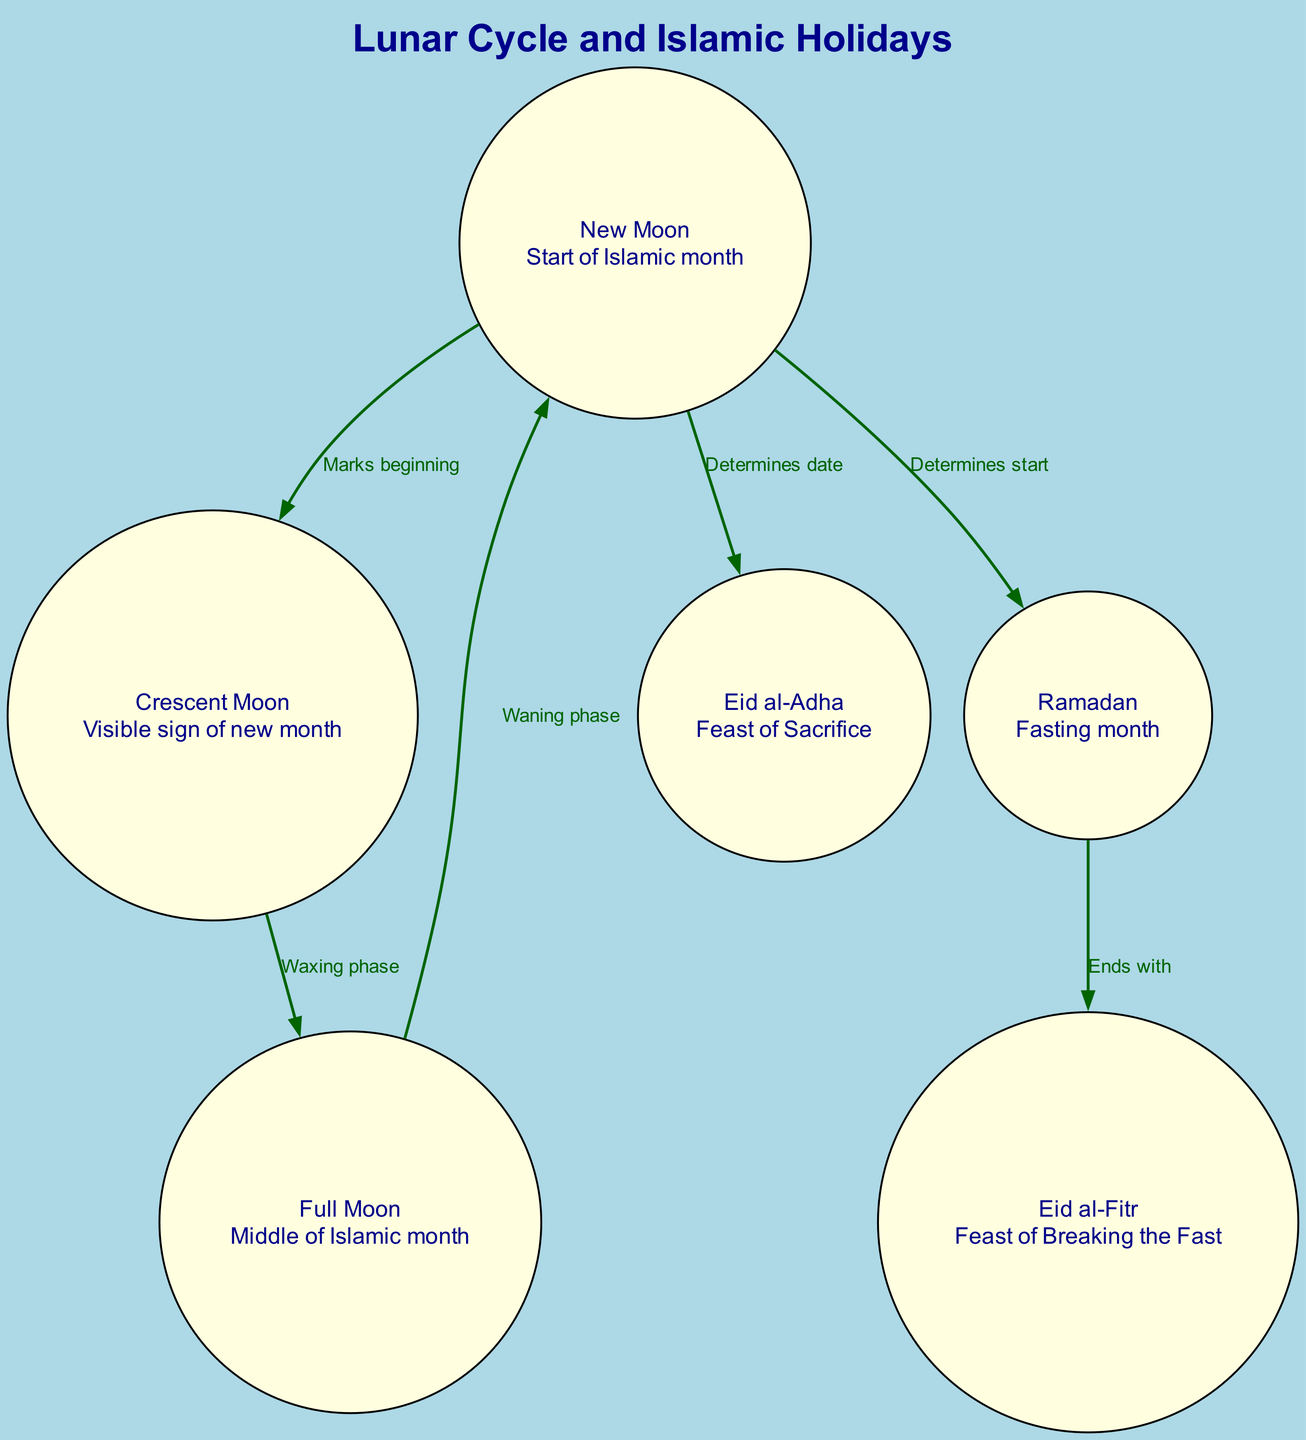What is the start of the Islamic month? The diagram explicitly labels "New Moon" as the starting point of the Islamic month, making it clear that the lunar cycle begins at this phase.
Answer: New Moon How many Islamic holidays are represented in the diagram? By counting the distinct nodes under the "Lunar Cycle and Islamic Holidays" concept, we find there are three key Islamic holidays: Ramadan, Eid al-Fitr, and Eid al-Adha.
Answer: 3 What phase comes after the Crescent Moon? The diagram illustrates that the Crescent Moon is followed by the Full Moon in the waxing phase, which indicates the progression of the lunar cycle towards fuller illumination.
Answer: Full Moon What event marks the end of Ramadan? The diagram connects the end of Ramadan directly to Eid al-Fitr, showcasing that this holiday is celebrated immediately after the fasting month concludes.
Answer: Eid al-Fitr Which phase of the moon determines the start of Ramadan? The edge from the New Moon to Ramadan indicates that the New Moon phase is what determines the beginning of the fasting month.
Answer: New Moon What relationship exists between New Moon and Eid al-Adha? The connection between the New Moon and Eid al-Adha shows that the New Moon phase determines the date of this holiday, indicating its dependence on lunar observations.
Answer: Determines date What occurs during the waxing phase? The diagram indicates that during the waxing phase, the cycle goes from the Crescent Moon to the Full Moon, which signifies an increase in visible moonlight.
Answer: Waxing phase What event is represented by the Full Moon? According to the diagram, the Full Moon represents the middle of the Islamic month, marking a crucial point in the lunar cycle.
Answer: Middle of Islamic month What does the Crescent Moon represent? The diagram clearly defines the Crescent Moon as the visible sign of the new month in the lunar cycle, indicating its importance for marking the start of each month.
Answer: Visible sign of new month 